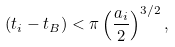<formula> <loc_0><loc_0><loc_500><loc_500>( t _ { i } - t _ { B } ) < \pi \left ( \frac { a _ { i } } { 2 } \right ) ^ { 3 / 2 } ,</formula> 